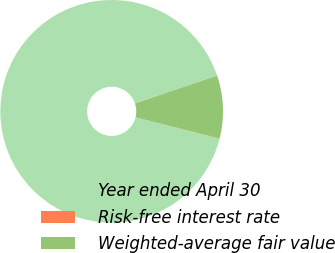<chart> <loc_0><loc_0><loc_500><loc_500><pie_chart><fcel>Year ended April 30<fcel>Risk-free interest rate<fcel>Weighted-average fair value<nl><fcel>90.85%<fcel>0.04%<fcel>9.12%<nl></chart> 